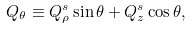<formula> <loc_0><loc_0><loc_500><loc_500>Q _ { \theta } \equiv Q ^ { s } _ { \rho } \sin \theta + Q ^ { s } _ { z } \cos \theta ,</formula> 